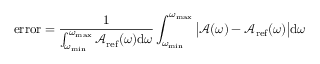Convert formula to latex. <formula><loc_0><loc_0><loc_500><loc_500>e r r o r = \frac { 1 } { \int _ { \omega _ { \min } } ^ { \omega _ { \max } } \mathcal { A } _ { r e f } ( \omega ) d \omega } \int _ { \omega _ { \min } } ^ { \omega _ { \max } } \left | \mathcal { A } ( \omega ) - \mathcal { A } _ { r e f } ( \omega ) \right | d \omega</formula> 